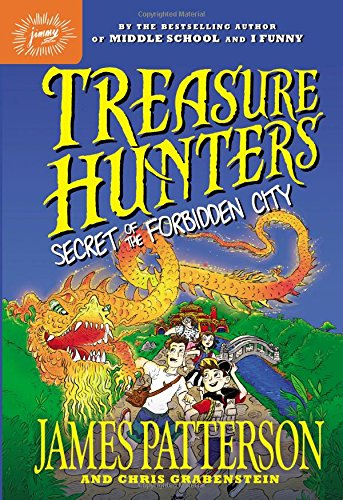What type of book is this? This book falls under the genre of Mystery, Thriller & Suspense, promising a thrilling and engaging read for its audience. 